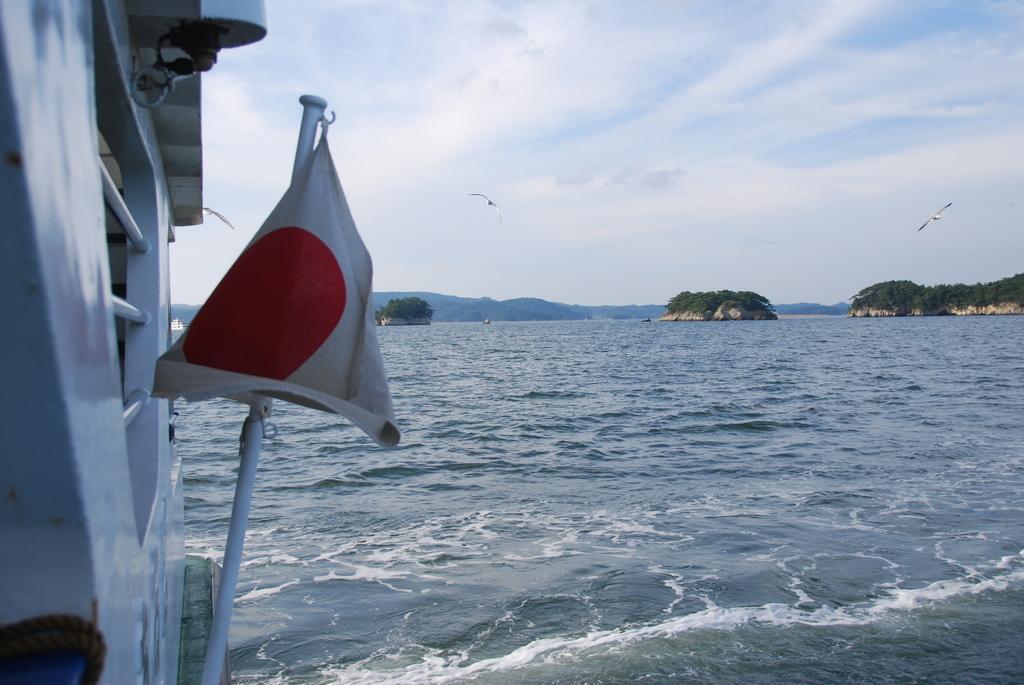In one or two sentences, can you explain what this image depicts? In this image we can see there is a ship in the water, there is a flag, on the right there are many trees, at the back there are mountains, there are birds flying in the sky, the sky is cloudy. 